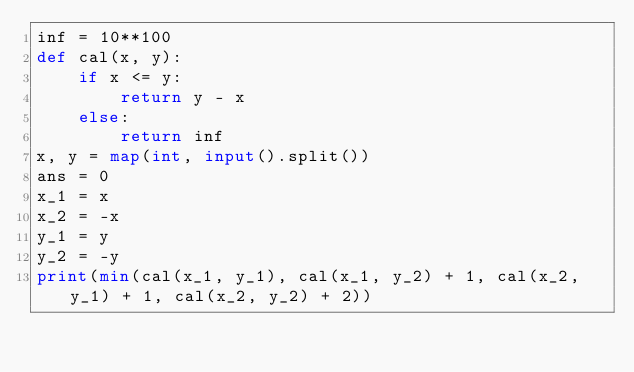<code> <loc_0><loc_0><loc_500><loc_500><_Python_>inf = 10**100
def cal(x, y):
    if x <= y:
        return y - x
    else:
        return inf
x, y = map(int, input().split())
ans = 0
x_1 = x
x_2 = -x
y_1 = y
y_2 = -y
print(min(cal(x_1, y_1), cal(x_1, y_2) + 1, cal(x_2, y_1) + 1, cal(x_2, y_2) + 2))</code> 